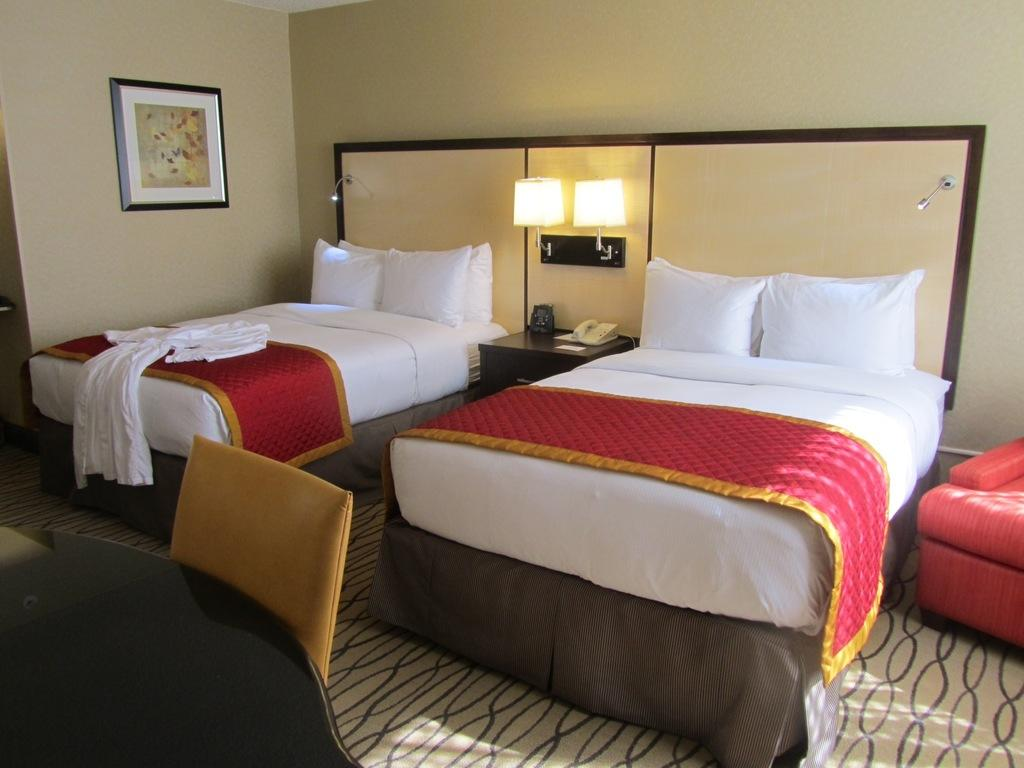How many beds are in the room? There are 2 beds in the room. What type of furniture is present for lighting purposes? There are 2 lamps in the room. What type of seating is available in the room? There are chairs in the room. What can be seen hanging on the wall? There is a frame on the wall. Can you tell me who is helping the person in the argument in the room? There is no argument or person being helped in the image; it only shows 2 beds, 2 lamps, chairs, and a frame on the wall. What caused the spark between the two people in the room? There are no people or sparks present in the image; it only shows furniture and a frame on the wall. 